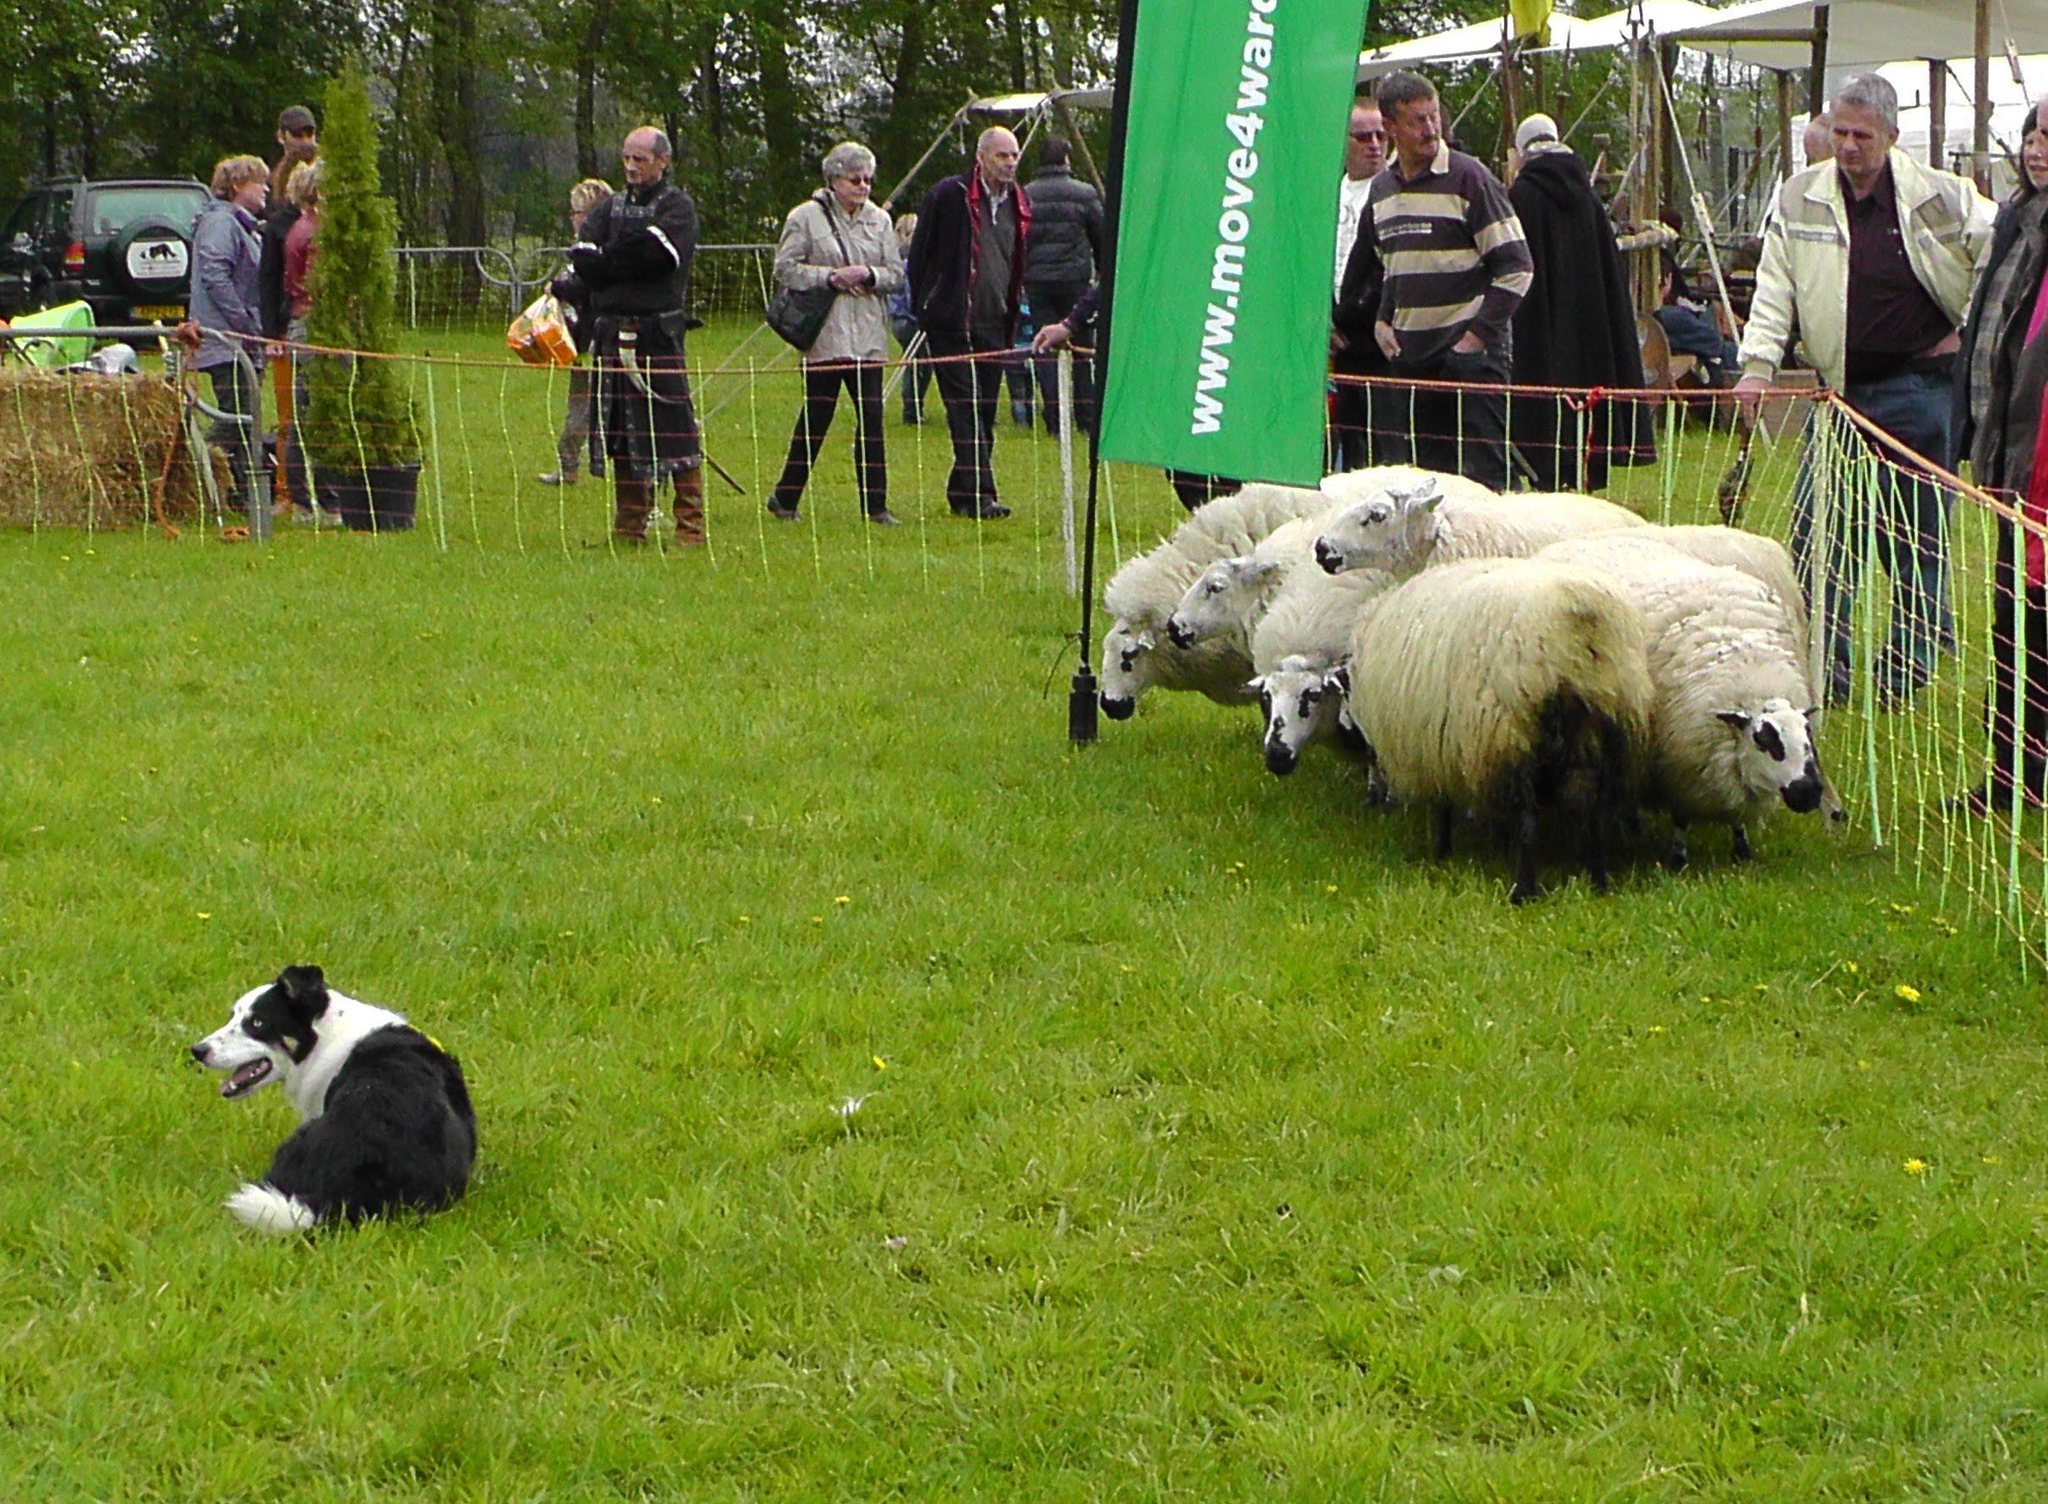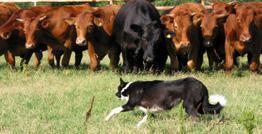The first image is the image on the left, the second image is the image on the right. Examine the images to the left and right. Is the description "At least one image features only a black and white dog, with no livestock." accurate? Answer yes or no. No. The first image is the image on the left, the second image is the image on the right. Considering the images on both sides, is "The right image shows only one animal." valid? Answer yes or no. No. 